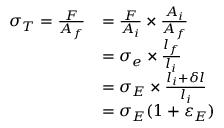Convert formula to latex. <formula><loc_0><loc_0><loc_500><loc_500>{ \begin{array} { r l } { \sigma _ { T } = { \frac { F } { A _ { f } } } } & { = { \frac { F } { A _ { i } } } \times { \frac { A _ { i } } { A _ { f } } } } \\ & { = \sigma _ { e } \times { \frac { l _ { f } } { l _ { i } } } } \\ & { = \sigma _ { E } \times { \frac { l _ { i } + \delta l } { l _ { i } } } } \\ & { = \sigma _ { E } ( 1 + \varepsilon _ { E } ) } \end{array} }</formula> 